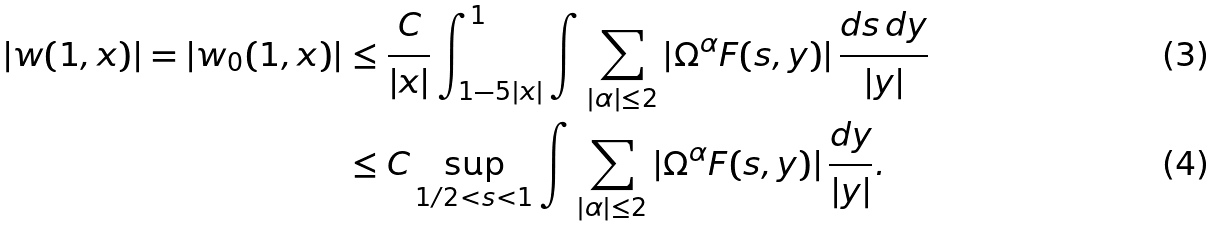<formula> <loc_0><loc_0><loc_500><loc_500>| w ( 1 , x ) | = | w _ { 0 } ( 1 , x ) | & \leq \frac { C } { | x | } \int ^ { 1 } _ { 1 - 5 | x | } \int \sum _ { | \alpha | \leq 2 } | \Omega ^ { \alpha } F ( s , y ) | \, \frac { d s \, d y } { | y | } \\ & \leq C \sup _ { 1 / 2 < s < 1 } \int \sum _ { | \alpha | \leq 2 } | \Omega ^ { \alpha } F ( s , y ) | \, \frac { d y } { | y | } .</formula> 